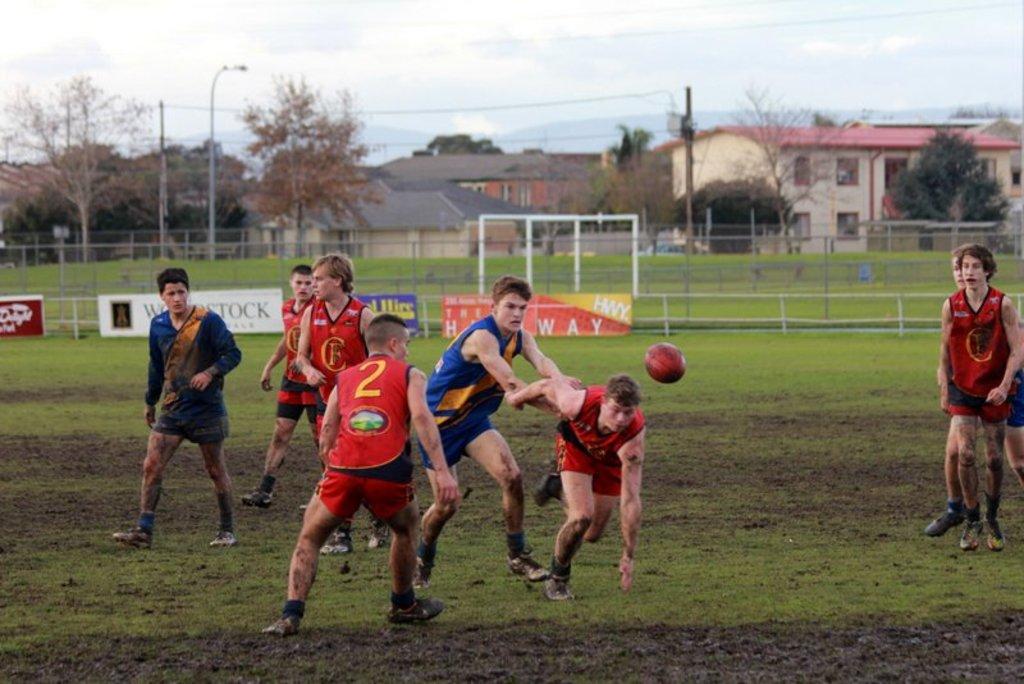What is the jersey number of the man in the red jersey?
Offer a very short reply. 2. 